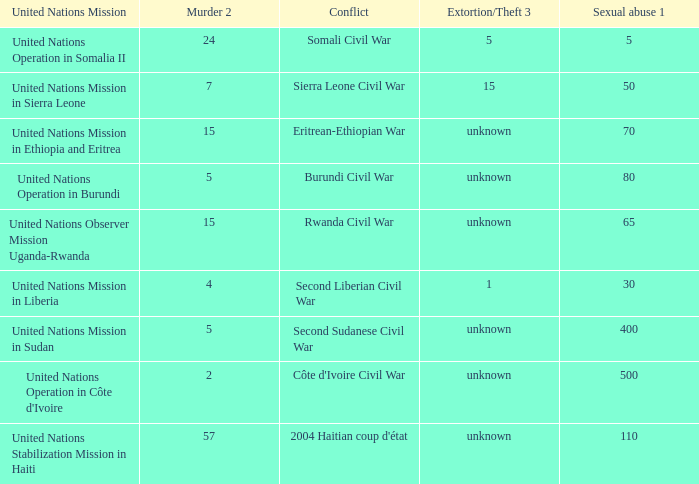What is the extortion and theft rates where the United Nations Observer Mission Uganda-Rwanda is active? Unknown. 